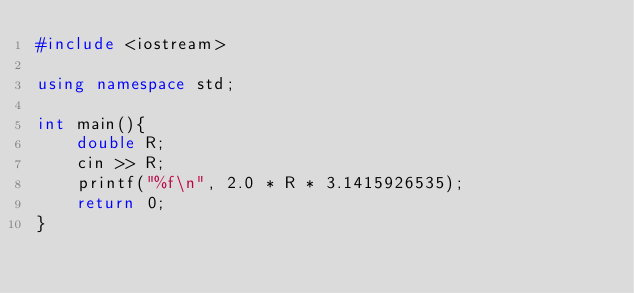Convert code to text. <code><loc_0><loc_0><loc_500><loc_500><_C++_>#include <iostream>

using namespace std;

int main(){
    double R;
    cin >> R;
    printf("%f\n", 2.0 * R * 3.1415926535);
    return 0;
}</code> 